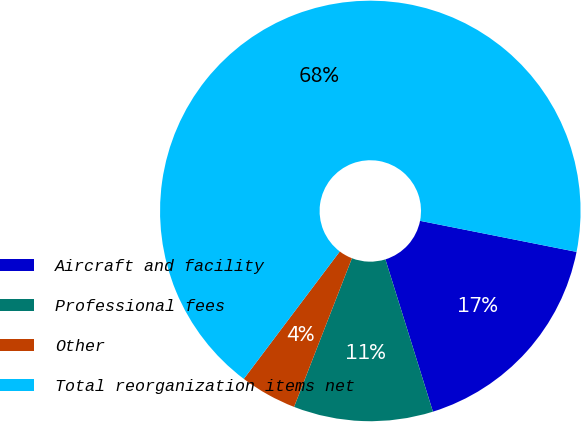Convert chart. <chart><loc_0><loc_0><loc_500><loc_500><pie_chart><fcel>Aircraft and facility<fcel>Professional fees<fcel>Other<fcel>Total reorganization items net<nl><fcel>17.07%<fcel>10.72%<fcel>4.37%<fcel>67.85%<nl></chart> 